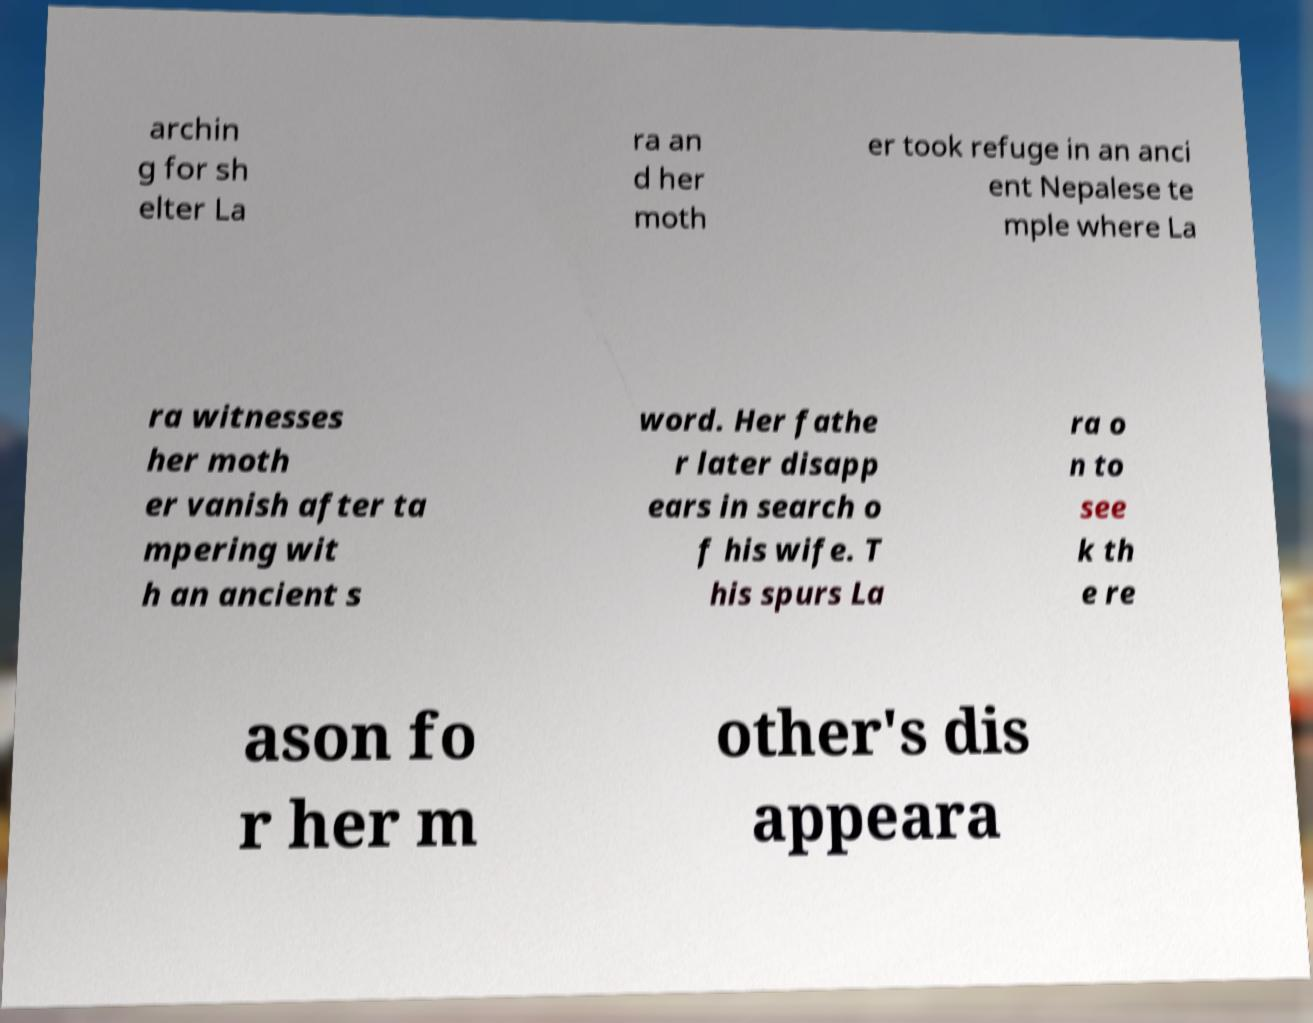What messages or text are displayed in this image? I need them in a readable, typed format. archin g for sh elter La ra an d her moth er took refuge in an anci ent Nepalese te mple where La ra witnesses her moth er vanish after ta mpering wit h an ancient s word. Her fathe r later disapp ears in search o f his wife. T his spurs La ra o n to see k th e re ason fo r her m other's dis appeara 